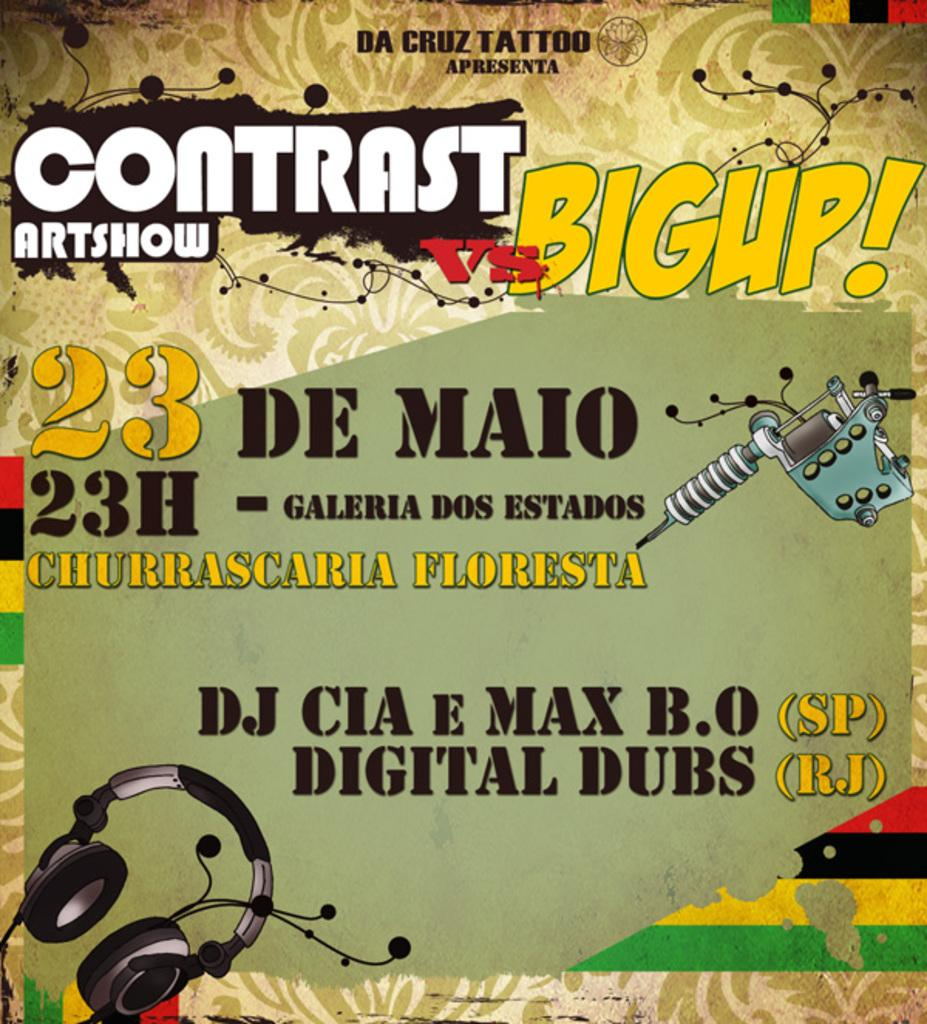Provide a one-sentence caption for the provided image. A music concert with DJ CIA and digital Dubs is being advertised on a poster. 